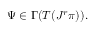<formula> <loc_0><loc_0><loc_500><loc_500>\Psi \in \Gamma ( T ( J ^ { r } \pi ) ) .</formula> 